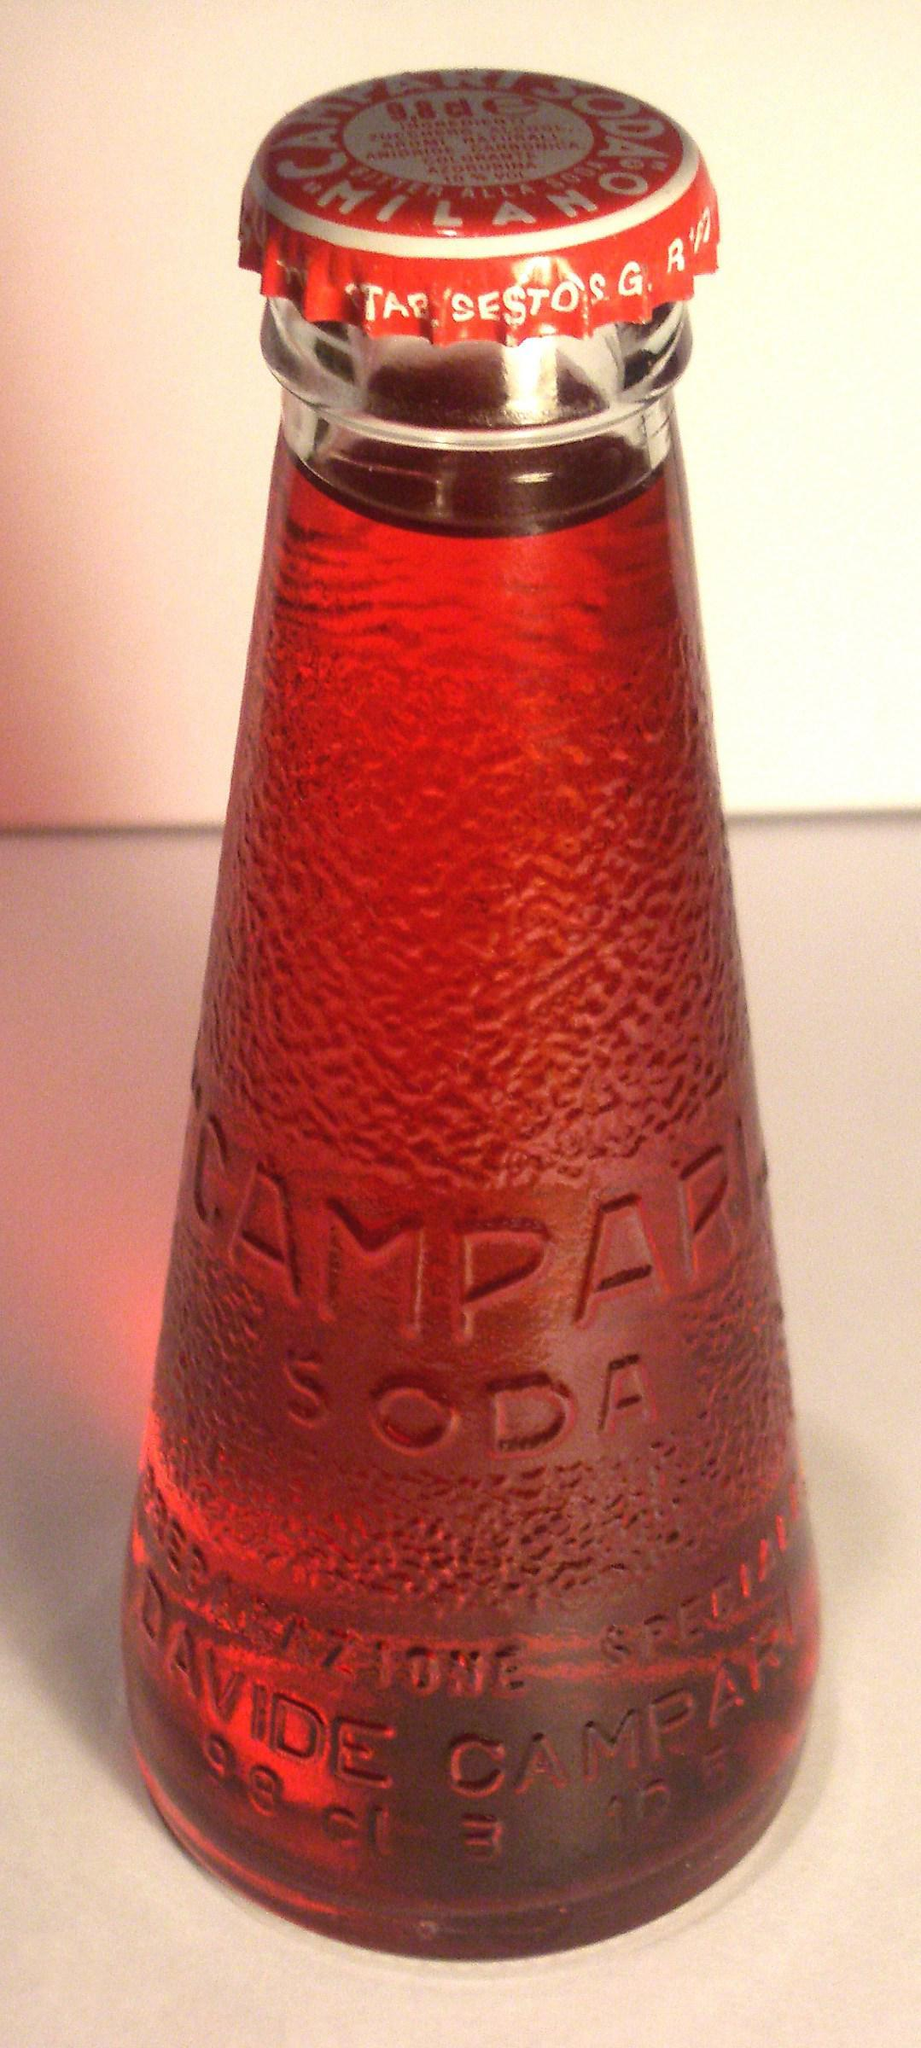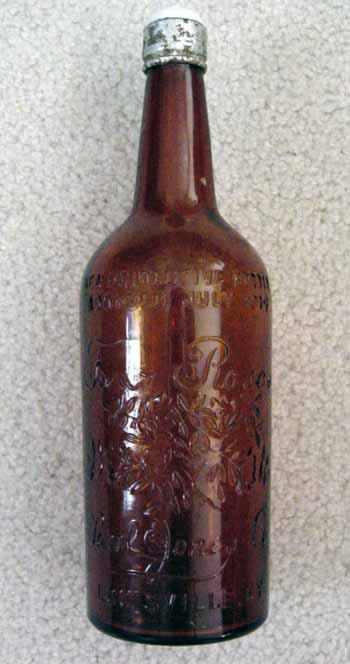The first image is the image on the left, the second image is the image on the right. Evaluate the accuracy of this statement regarding the images: "Each image shows one bottle with a cap on it, and one image features a bottle that tapers from its base, has a textured surface but no label, and contains a red liquid.". Is it true? Answer yes or no. Yes. The first image is the image on the left, the second image is the image on the right. Considering the images on both sides, is "There are labels on each of the bottles." valid? Answer yes or no. No. 